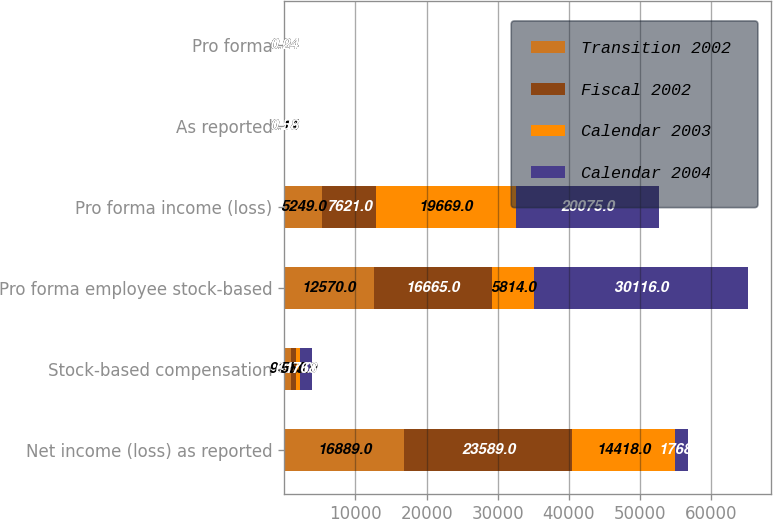<chart> <loc_0><loc_0><loc_500><loc_500><stacked_bar_chart><ecel><fcel>Net income (loss) as reported<fcel>Stock-based compensation<fcel>Pro forma employee stock-based<fcel>Pro forma income (loss)<fcel>As reported<fcel>Pro forma<nl><fcel>Transition 2002<fcel>16889<fcel>930<fcel>12570<fcel>5249<fcel>0.14<fcel>0.04<nl><fcel>Fiscal 2002<fcel>23589<fcel>697<fcel>16665<fcel>7621<fcel>0.26<fcel>0.08<nl><fcel>Calendar 2003<fcel>14418<fcel>563<fcel>5814<fcel>19669<fcel>0.18<fcel>0.24<nl><fcel>Calendar 2004<fcel>1768<fcel>1768<fcel>30116<fcel>20075<fcel>0.58<fcel>0.24<nl></chart> 